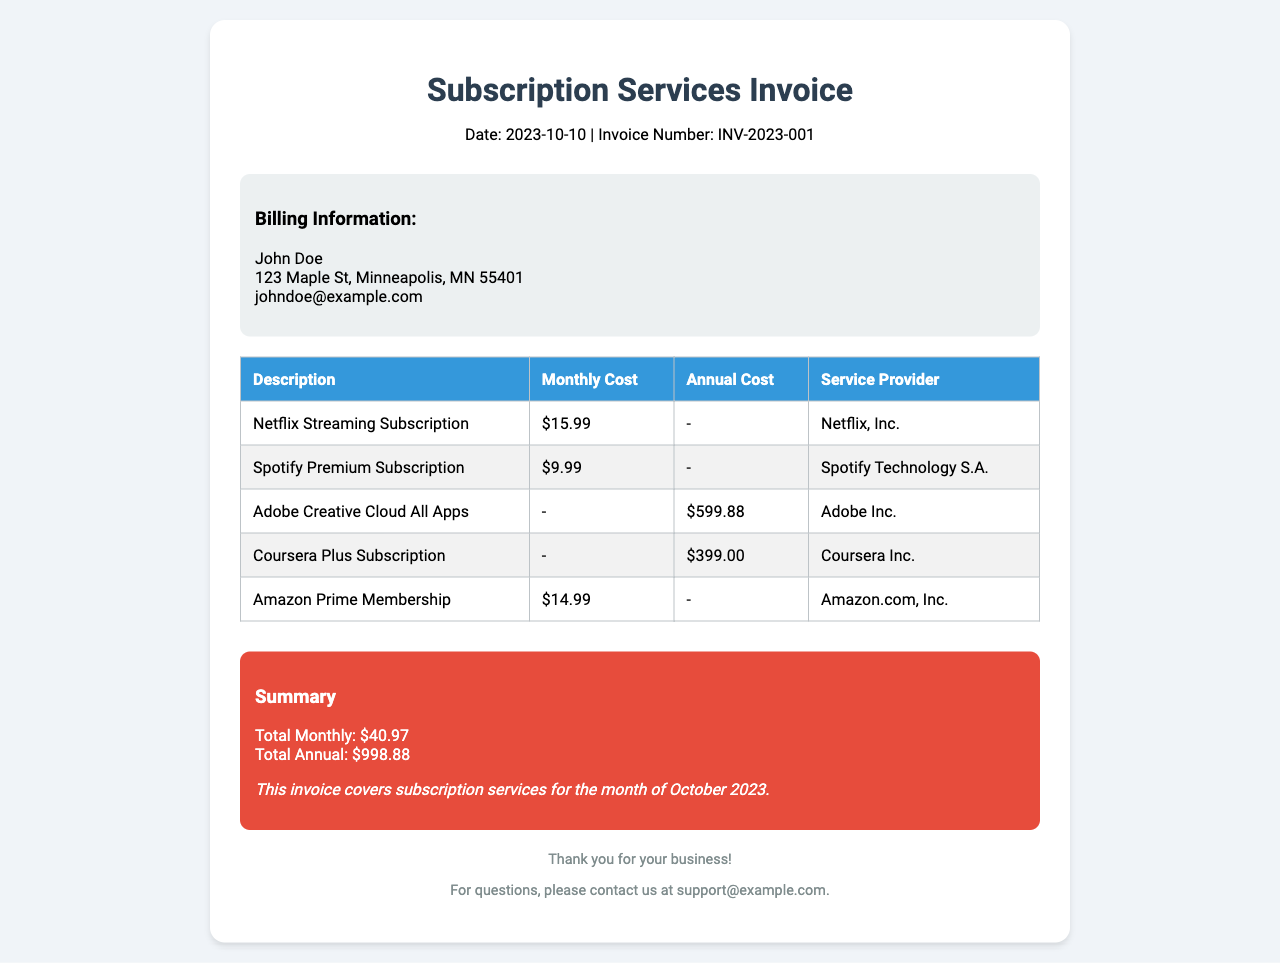What is the date of the invoice? The date of the invoice is stated at the top of the document as "Date: 2023-10-10".
Answer: 2023-10-10 Who is the billed customer? The billing information section includes the name of the customer, which is "John Doe".
Answer: John Doe How much is the monthly cost for Netflix? The services table lists the monthly cost for Netflix as "$15.99".
Answer: $15.99 What is the total annual cost? The summary section provides the total annual cost, which is "$998.88".
Answer: $998.88 Which streaming service has the highest monthly cost? By comparing the monthly costs listed, Netflix has the highest monthly cost at "$15.99".
Answer: Netflix What is the service provider for Adobe Creative Cloud? The services table mentions "Adobe Inc." as the service provider for Adobe Creative Cloud.
Answer: Adobe Inc How many subscription services have an annual cost listed? There are two subscriptions with an annual cost listed in the document: Adobe Creative Cloud and Coursera Plus.
Answer: Two What is the total monthly cost? The total monthly cost is provided in the summary as "$40.97".
Answer: $40.97 What email is provided for support inquiries? The footer section includes a support contact email, "support@example.com".
Answer: support@example.com 